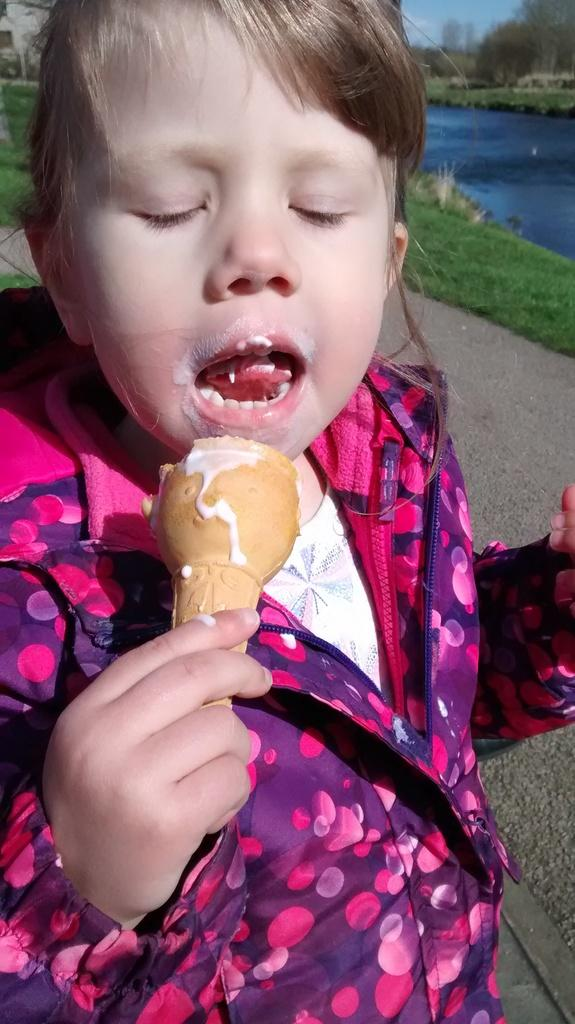What is the main subject of the image? There is a child in the image. What is the child doing in the image? The child is eating ice-cream. What type of surface is the child walking on? The child is walking on a concrete surface. What type of vegetation can be seen in the image? Grass, trees, and plants are present in the image. What is the color of the sky in the image? The sky is blue in the image. What type of plot is the child involved in the image? There is no plot present in the image. The image is a snapshot of a child eating ice-cream and walking on a concrete surface. --- Facts: 1. There is a car in the image. 12. The car is red. 13. The car has four wheels. 14. The car has a sunroof. 15. The car is parked on a street. 16. There are buildings in the background. 17. There are people walking on the sidewalk. 18. There is a traffic light on the street corner. Absurd Topics: unicorn, rainbow, magic wand Conversation: What is the main subject in the image? There is a car in the image. What color is the car? The car is red. How many wheels does the car have? The car has four wheels. What special feature does the car have? The car has a sunroof. Where is the car located in the image? The car is parked on a street. What can be seen in the background of the image? There are buildings in the background. What is happening around the car in the image? There are people walking on the sidewalk. What traffic control device can be seen in the image? There is a traffic light on the street corner. Reasoning: Let's think step by step in order to produce the conversation. We start by identifying the main subject of the image, which is the car. Then, we describe specific features of the car, such as its color, number of wheels, and special features like the sunroof. Next, we observe the car's location in the image, which is parked on a street. We then describe the background of the image, which includes buildings. After that, we observe the actions of the people around the car in the image, who are walking on the sidewalk. Finally, we describe the traffic control device that can be seen in the image, which is a traffic light on the street corner. Absurd Question/Answer: Can you see a unicorn in the image? No, there is no unicorn present in the image. The image features a red car with a sunroof, parked on a street, with buildings in the background, people walking on the sidewalk, and a traffic light on the street corner. --- Facts: 1. 